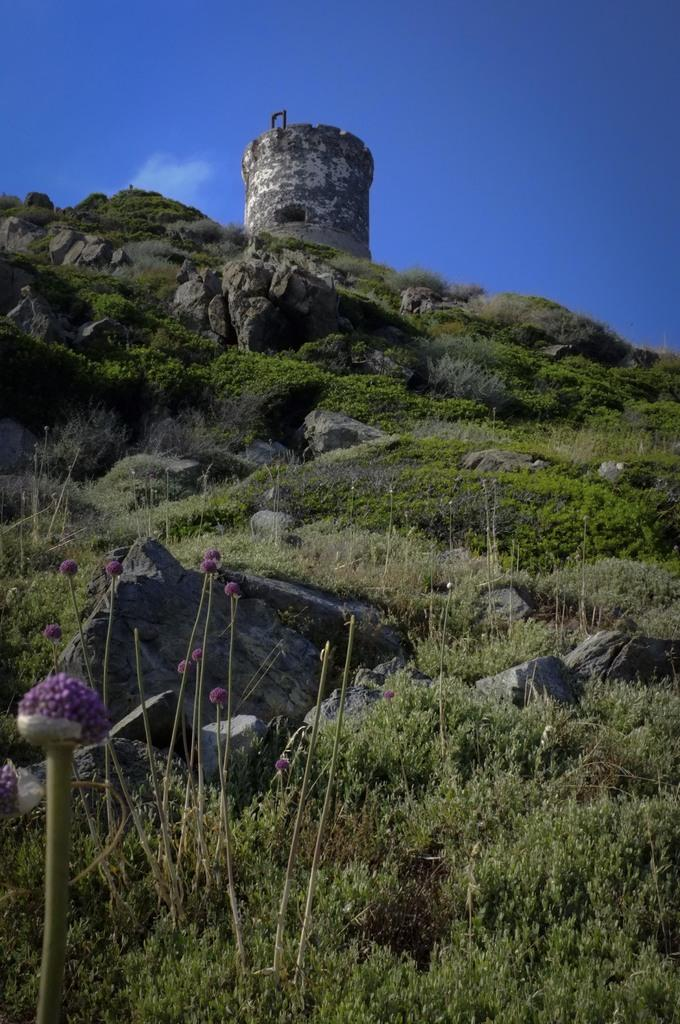What type of natural formation is present in the image? There is a hill in the image. What can be found on the hill? There are plants, grass, and rocks on the hill. What is located at the top of the hill? There is a building-like structure at the top of the hill. What type of stem can be seen growing from the plants on the hill? There is no specific stem mentioned in the image, as it only describes the presence of plants on the hill. 